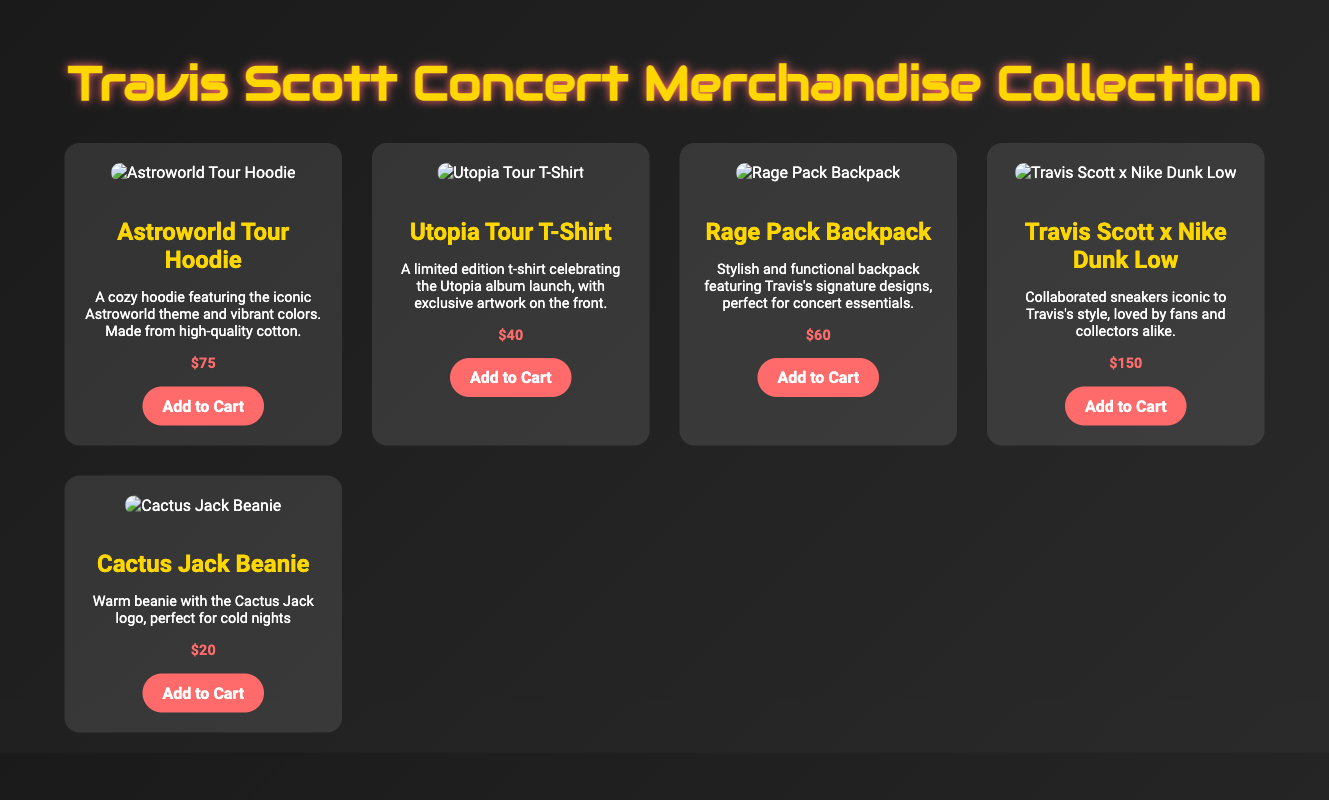What is the price of the Astroworld Tour Hoodie? The price of the Astroworld Tour Hoodie is listed in the document as $75.
Answer: $75 What is featured on the Utopia Tour T-Shirt? The Utopia Tour T-Shirt features exclusive artwork on the front celebrating the Utopia album launch.
Answer: Exclusive artwork How much does the Rage Pack Backpack cost? The cost of the Rage Pack Backpack is provided in the document as $60.
Answer: $60 What item is associated with Travis Scott's signature designs? The item associated with Travis Scott's signature designs is the Rage Pack Backpack.
Answer: Rage Pack Backpack What material is the Astroworld Tour Hoodie made from? The material of the Astroworld Tour Hoodie is specifically mentioned as high-quality cotton.
Answer: High-quality cotton How much are the Travis Scott x Nike Dunk Low sneakers? The price for the Travis Scott x Nike Dunk Low sneakers is noted as $150.
Answer: $150 What is the name of the beanie in the merchandise collection? The name of the beanie is the Cactus Jack Beanie as stated in the document.
Answer: Cactus Jack Beanie What is the main purpose of the Rage Pack Backpack? The main purpose of the Rage Pack Backpack, as mentioned in the document, is for concert essentials.
Answer: Concert essentials Which item features the Cactus Jack logo? The item featuring the Cactus Jack logo is the Cactus Jack Beanie.
Answer: Cactus Jack Beanie 